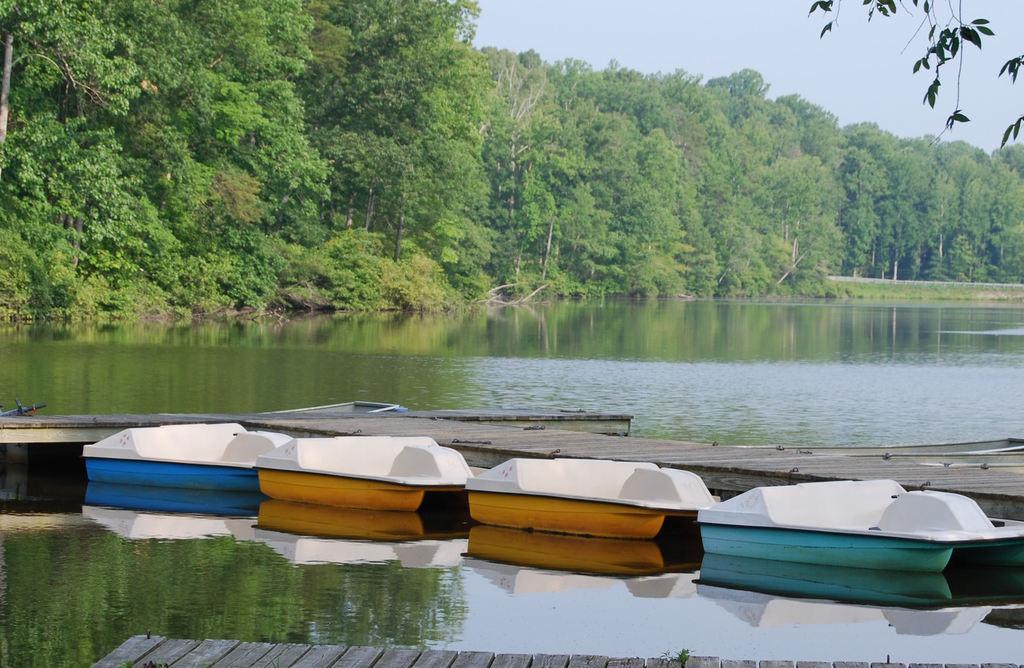Could you give a brief overview of what you see in this image? In this picture, we can see we can see wooden paths, boats, water, trees, and the sky. 